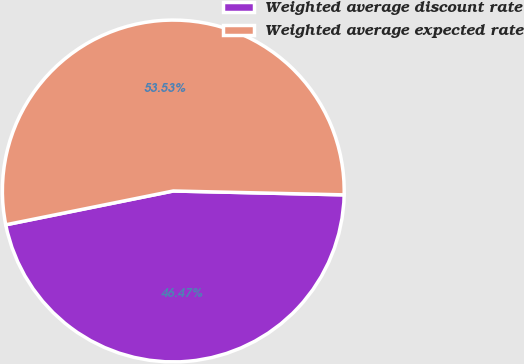Convert chart. <chart><loc_0><loc_0><loc_500><loc_500><pie_chart><fcel>Weighted average discount rate<fcel>Weighted average expected rate<nl><fcel>46.47%<fcel>53.53%<nl></chart> 